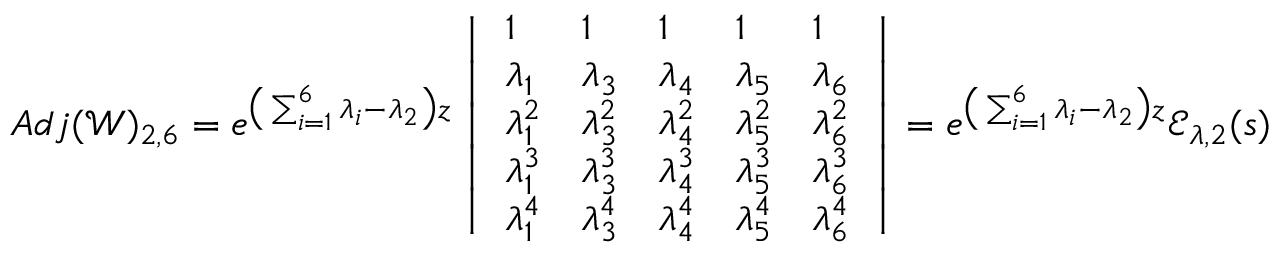Convert formula to latex. <formula><loc_0><loc_0><loc_500><loc_500>A d j ( \ m a t h s c r { W } ) _ { 2 , 6 } = e ^ { \left ( \sum _ { i = 1 } ^ { 6 } \lambda _ { i } - \lambda _ { 2 } \right ) z } \left | \begin{array} { l l l l l } { 1 } & { 1 } & { 1 } & { 1 } & { 1 } \\ { \lambda _ { 1 } } & { \lambda _ { 3 } } & { \lambda _ { 4 } } & { \lambda _ { 5 } } & { \lambda _ { 6 } } \\ { \lambda _ { 1 } ^ { 2 } } & { \lambda _ { 3 } ^ { 2 } } & { \lambda _ { 4 } ^ { 2 } } & { \lambda _ { 5 } ^ { 2 } } & { \lambda _ { 6 } ^ { 2 } } \\ { \lambda _ { 1 } ^ { 3 } } & { \lambda _ { 3 } ^ { 3 } } & { \lambda _ { 4 } ^ { 3 } } & { \lambda _ { 5 } ^ { 3 } } & { \lambda _ { 6 } ^ { 3 } } \\ { \lambda _ { 1 } ^ { 4 } } & { \lambda _ { 3 } ^ { 4 } } & { \lambda _ { 4 } ^ { 4 } } & { \lambda _ { 5 } ^ { 4 } } & { \lambda _ { 6 } ^ { 4 } } \end{array} \right | = e ^ { \left ( \sum _ { i = 1 } ^ { 6 } \lambda _ { i } - \lambda _ { 2 } \right ) z } \ m a t h s c r { E } _ { \lambda , 2 } ( s )</formula> 